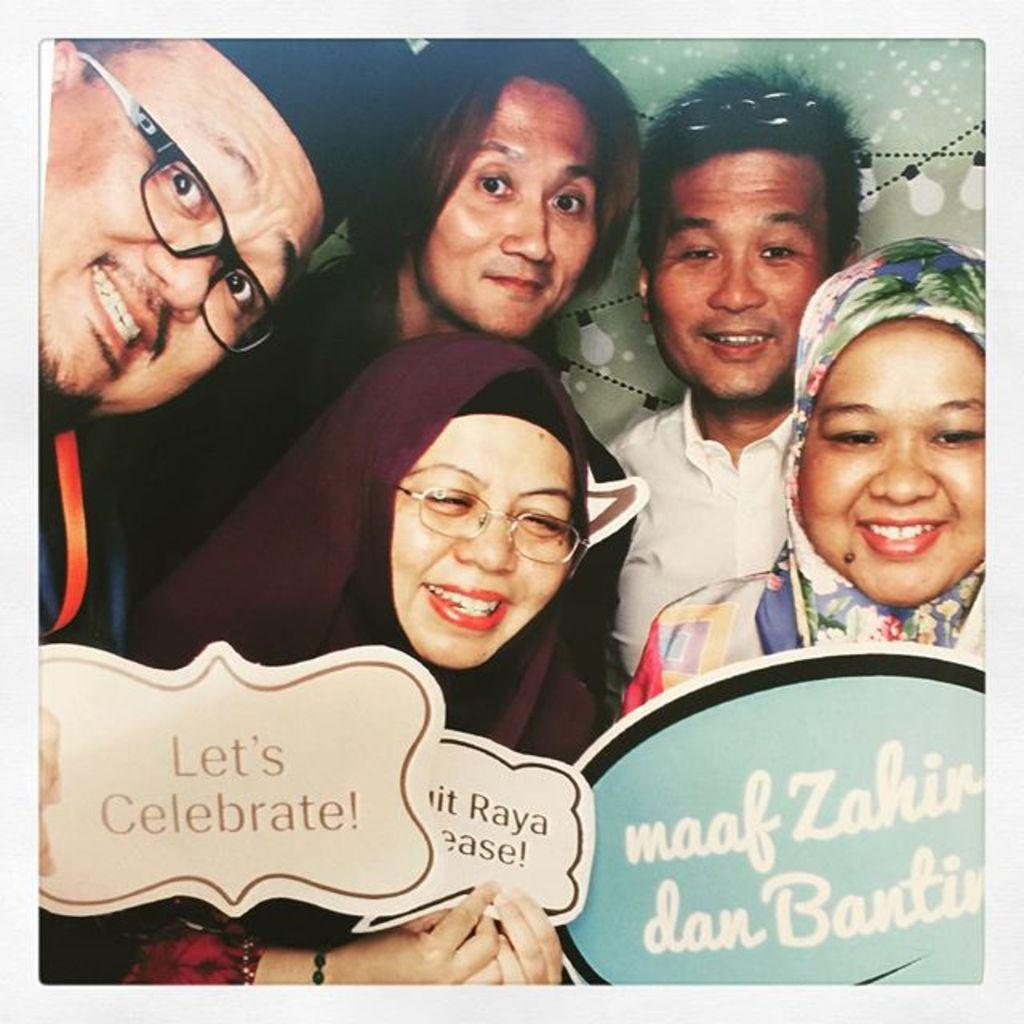How many people are in the image? There are many people in the image. What are the people wearing? The people are wearing clothes. Can you identify any specific accessories worn by some people? Two people are wearing spectacles. What else can be seen in the image besides the people? There is a greeting paper and a poster in the image. What type of leather is visible on the people in the image? There is no leather visible on the people in the image. How many pies can be seen on the poster in the image? There is no pie mentioned or visible in the image. 